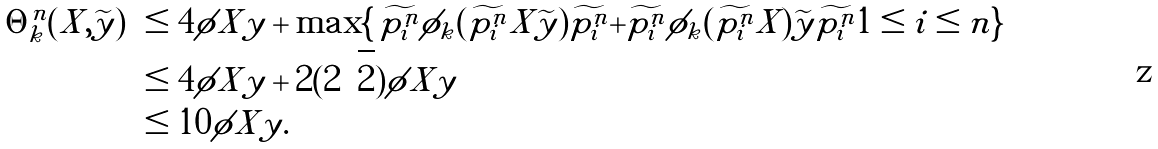<formula> <loc_0><loc_0><loc_500><loc_500>\| \Theta ^ { n } _ { k } ( X , \widetilde { y } ) \| & \leq 4 \| \phi \| X \| y \| + \max \{ \, \| \widetilde { p ^ { n } _ { i } } \phi _ { k } ( \widetilde { p ^ { n } _ { i } } X \widetilde { y } ) \widetilde { p ^ { n } _ { i } } \| + \| \widetilde { p ^ { n } _ { i } } \phi _ { k } ( \widetilde { p ^ { n } _ { i } } X ) \widetilde { y } \widetilde { p ^ { n } _ { i } } \| | 1 \leq i \leq n \} \\ & \leq 4 \| \phi \| X \| y \| + 2 ( 2 \sqrt { 2 } ) \| \phi \| X \| y \| \\ & \leq 1 0 \| \phi \| X \| y \| .</formula> 